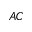Convert formula to latex. <formula><loc_0><loc_0><loc_500><loc_500>_ { A C }</formula> 